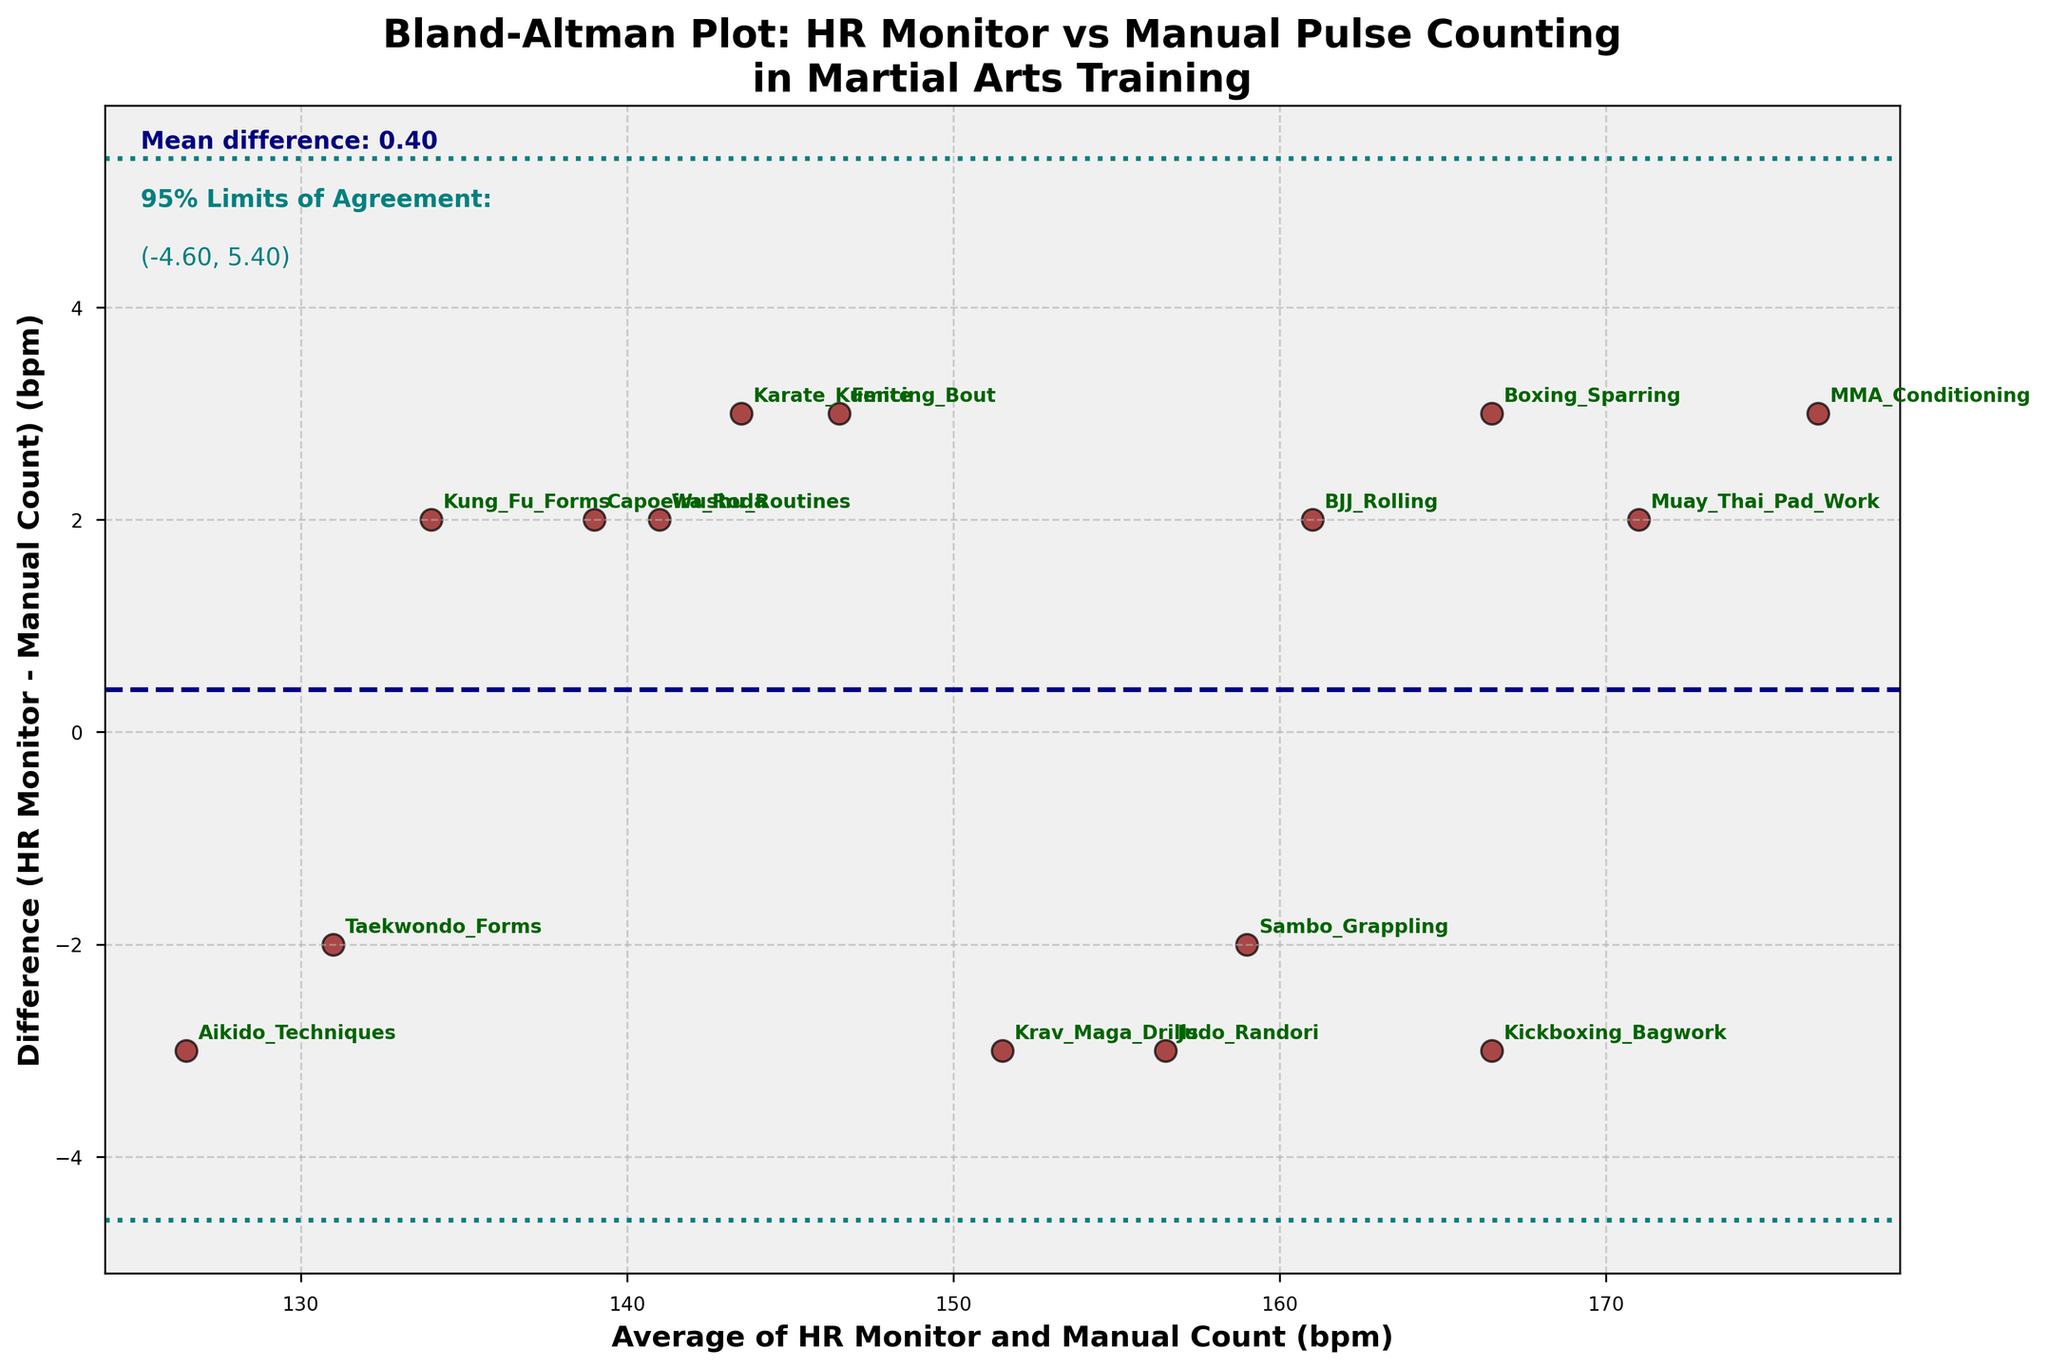What is the title of the Bland-Altman plot? The title of the plot is provided at the top of the figure.
Answer: Bland-Altman Plot: HR Monitor vs Manual Pulse Counting in Martial Arts Training How many data points are plotted in the Bland-Altman plot? Each data point corresponds to a row in the data table. Counting the rows tells us how many data points there are.
Answer: 15 What is the mean difference shown in the plot? The mean difference is denoted by a horizontal dashed line and labeled with text in the plot.
Answer: 0.60 What do the teal dotted lines represent? The teal dotted lines represent the 95% Limits of Agreement, which are typically mean difference ± 1.96 times the standard deviation of the differences.
Answer: 95% Limits of Agreement Which martial arts method has the largest positive difference? Observing the data points' positions relative to the horitzontal axis, we find the highest point for positive differences.
Answer: Boxing Sparring What is the average heart rate for Judo Randori? The average for Judo Randori can be read directly from the data table under the 'Average' column.
Answer: 156.5 bpm What is the difference in heart rate for the method with the lowest average? The method with the lowest average can be found by examining the 'Average' column, and its difference value is reported directly next to it.
Answer: -3 bpm (Aikido Techniques) How many martial arts methods show a negative difference between HR Monitor and Manual Count? Count all instances where the 'Difference' value is negative in the data table.
Answer: 6 Which martial arts method falls outside the 95% Limits of Agreement? Points falling outside the teal dotted lines on the Bland-Altman plot are outside the 95% Limits of Agreement.
Answer: None What's the overall trend indicated by the mean difference line? The mean difference line helps indicate whether there is an overall bias in the heart rate monitors compared to manual counting. A mean near zero suggests no consistent overall bias.
Answer: Slightly positive bias 